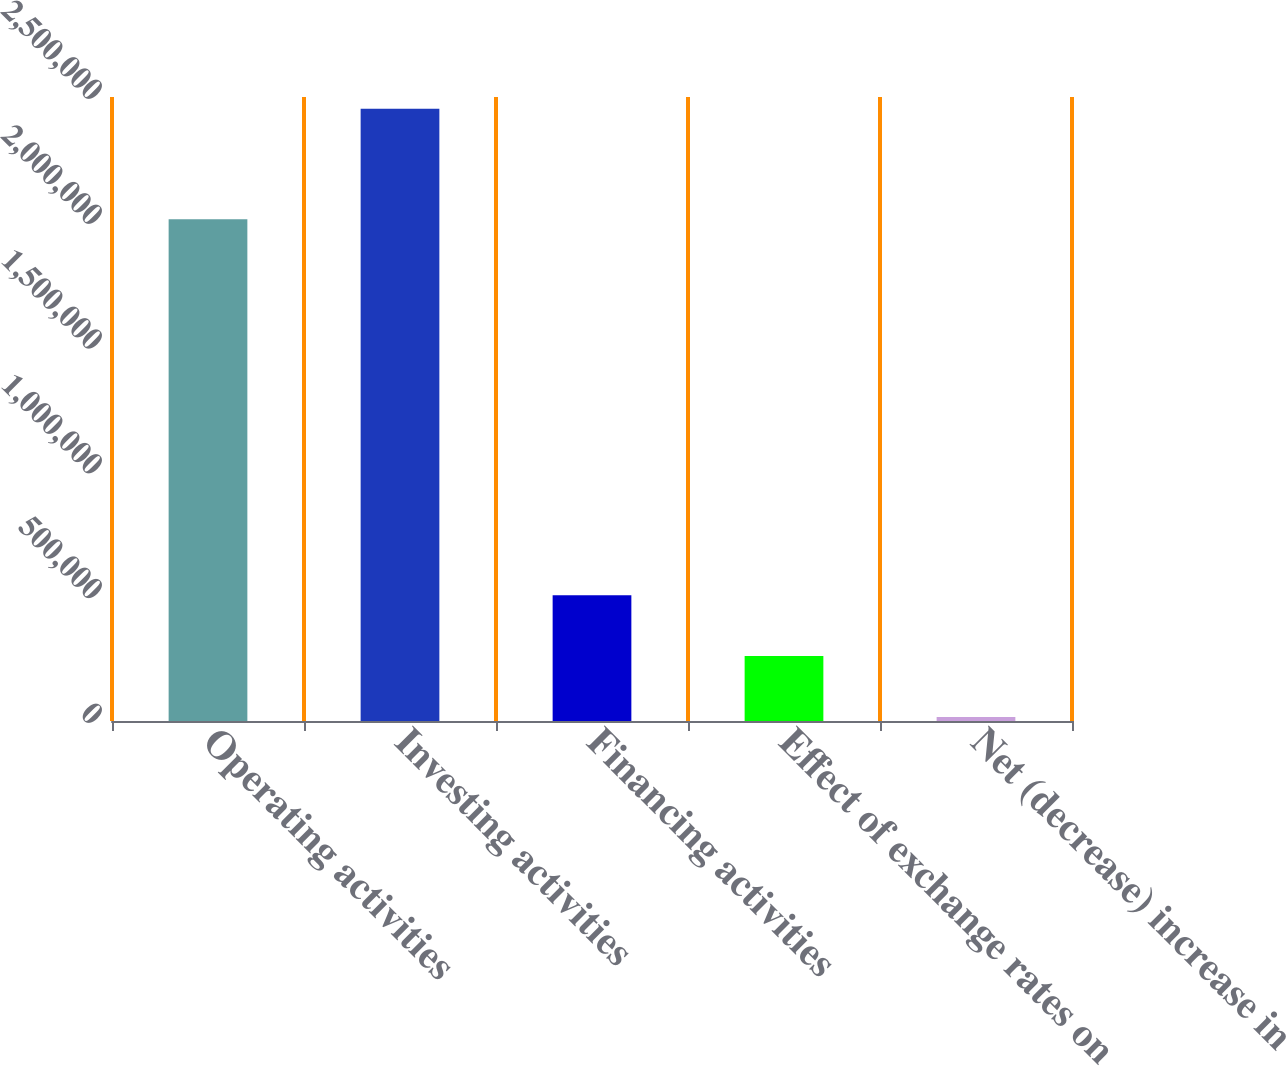<chart> <loc_0><loc_0><loc_500><loc_500><bar_chart><fcel>Operating activities<fcel>Investing activities<fcel>Financing activities<fcel>Effect of exchange rates on<fcel>Net (decrease) increase in<nl><fcel>2.00989e+06<fcel>2.45273e+06<fcel>503718<fcel>260092<fcel>16465<nl></chart> 